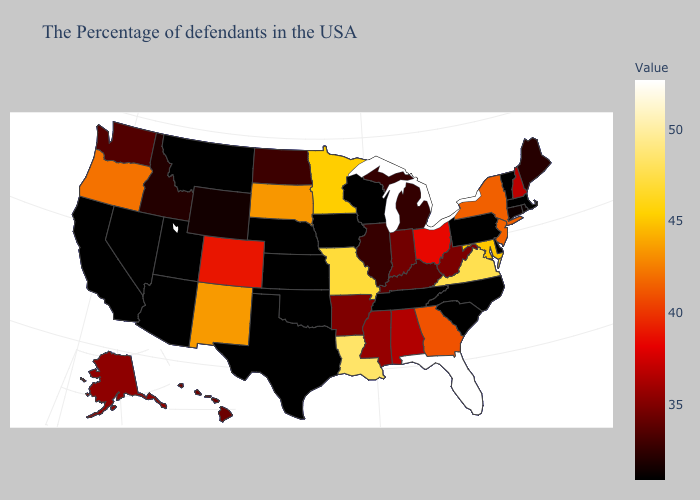Does Louisiana have a lower value than Florida?
Be succinct. Yes. Does Wyoming have the lowest value in the USA?
Answer briefly. No. Which states have the highest value in the USA?
Concise answer only. Florida. Does Maine have a higher value than Colorado?
Be succinct. No. Among the states that border Mississippi , does Tennessee have the lowest value?
Be succinct. Yes. 